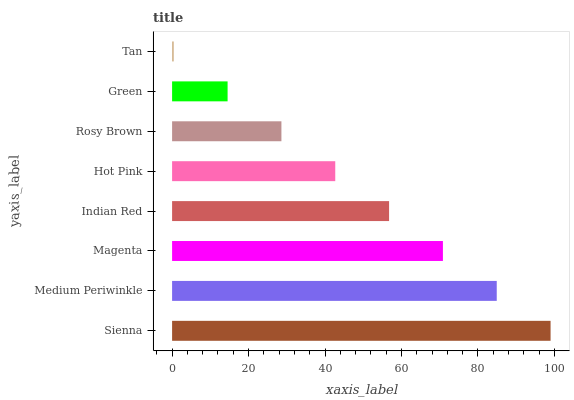Is Tan the minimum?
Answer yes or no. Yes. Is Sienna the maximum?
Answer yes or no. Yes. Is Medium Periwinkle the minimum?
Answer yes or no. No. Is Medium Periwinkle the maximum?
Answer yes or no. No. Is Sienna greater than Medium Periwinkle?
Answer yes or no. Yes. Is Medium Periwinkle less than Sienna?
Answer yes or no. Yes. Is Medium Periwinkle greater than Sienna?
Answer yes or no. No. Is Sienna less than Medium Periwinkle?
Answer yes or no. No. Is Indian Red the high median?
Answer yes or no. Yes. Is Hot Pink the low median?
Answer yes or no. Yes. Is Hot Pink the high median?
Answer yes or no. No. Is Sienna the low median?
Answer yes or no. No. 